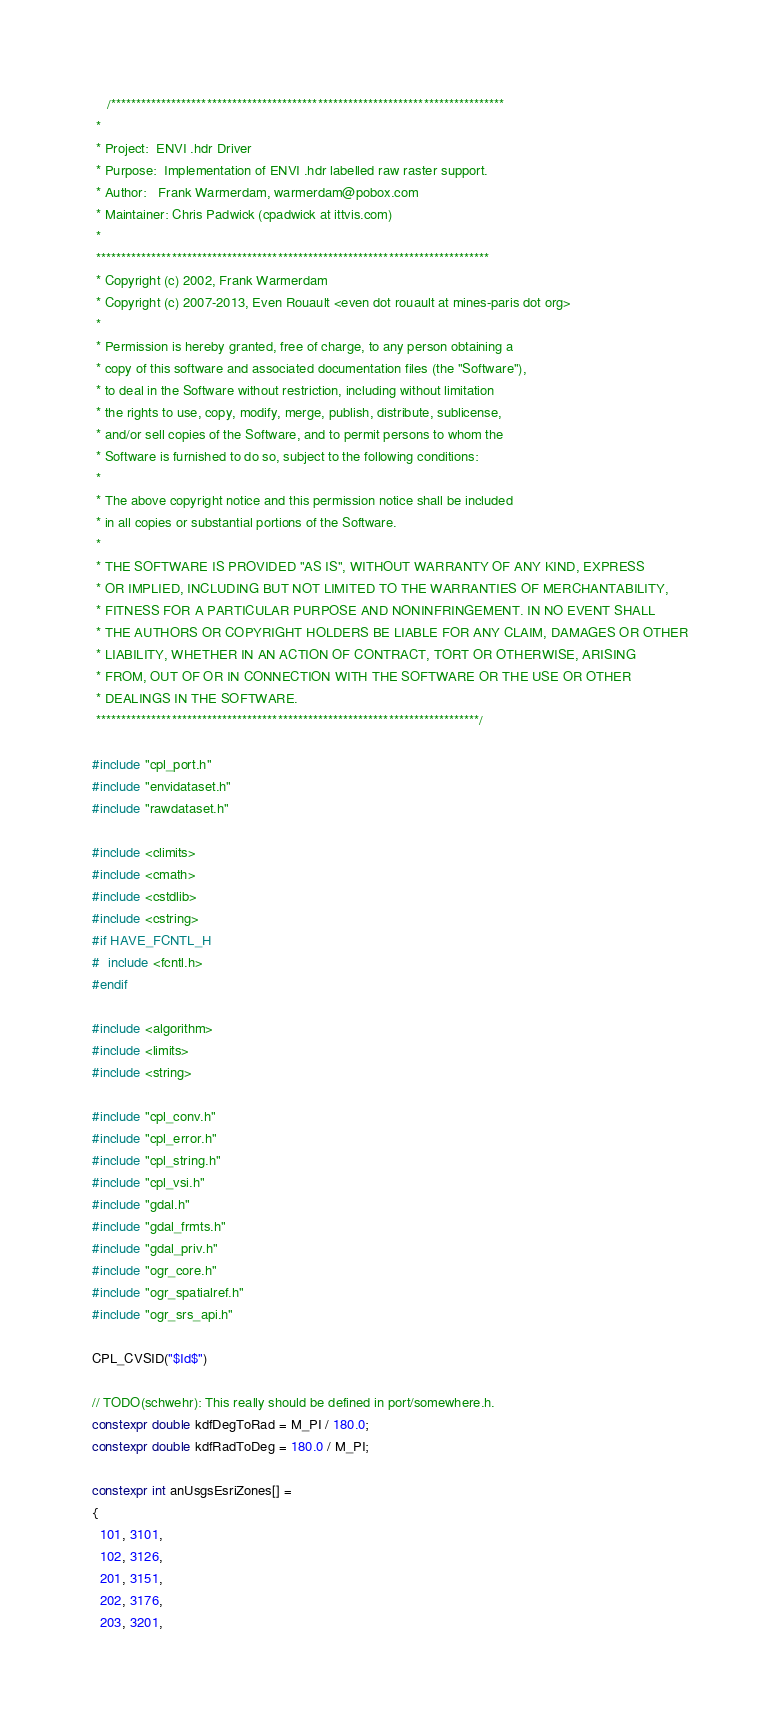Convert code to text. <code><loc_0><loc_0><loc_500><loc_500><_C++_>    /******************************************************************************
 *
 * Project:  ENVI .hdr Driver
 * Purpose:  Implementation of ENVI .hdr labelled raw raster support.
 * Author:   Frank Warmerdam, warmerdam@pobox.com
 * Maintainer: Chris Padwick (cpadwick at ittvis.com)
 *
 ******************************************************************************
 * Copyright (c) 2002, Frank Warmerdam
 * Copyright (c) 2007-2013, Even Rouault <even dot rouault at mines-paris dot org>
 *
 * Permission is hereby granted, free of charge, to any person obtaining a
 * copy of this software and associated documentation files (the "Software"),
 * to deal in the Software without restriction, including without limitation
 * the rights to use, copy, modify, merge, publish, distribute, sublicense,
 * and/or sell copies of the Software, and to permit persons to whom the
 * Software is furnished to do so, subject to the following conditions:
 *
 * The above copyright notice and this permission notice shall be included
 * in all copies or substantial portions of the Software.
 *
 * THE SOFTWARE IS PROVIDED "AS IS", WITHOUT WARRANTY OF ANY KIND, EXPRESS
 * OR IMPLIED, INCLUDING BUT NOT LIMITED TO THE WARRANTIES OF MERCHANTABILITY,
 * FITNESS FOR A PARTICULAR PURPOSE AND NONINFRINGEMENT. IN NO EVENT SHALL
 * THE AUTHORS OR COPYRIGHT HOLDERS BE LIABLE FOR ANY CLAIM, DAMAGES OR OTHER
 * LIABILITY, WHETHER IN AN ACTION OF CONTRACT, TORT OR OTHERWISE, ARISING
 * FROM, OUT OF OR IN CONNECTION WITH THE SOFTWARE OR THE USE OR OTHER
 * DEALINGS IN THE SOFTWARE.
 ****************************************************************************/

#include "cpl_port.h"
#include "envidataset.h"
#include "rawdataset.h"

#include <climits>
#include <cmath>
#include <cstdlib>
#include <cstring>
#if HAVE_FCNTL_H
#  include <fcntl.h>
#endif

#include <algorithm>
#include <limits>
#include <string>

#include "cpl_conv.h"
#include "cpl_error.h"
#include "cpl_string.h"
#include "cpl_vsi.h"
#include "gdal.h"
#include "gdal_frmts.h"
#include "gdal_priv.h"
#include "ogr_core.h"
#include "ogr_spatialref.h"
#include "ogr_srs_api.h"

CPL_CVSID("$Id$")

// TODO(schwehr): This really should be defined in port/somewhere.h.
constexpr double kdfDegToRad = M_PI / 180.0;
constexpr double kdfRadToDeg = 180.0 / M_PI;

constexpr int anUsgsEsriZones[] =
{
  101, 3101,
  102, 3126,
  201, 3151,
  202, 3176,
  203, 3201,</code> 